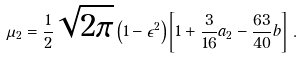Convert formula to latex. <formula><loc_0><loc_0><loc_500><loc_500>\mu _ { 2 } = \frac { 1 } { 2 } \sqrt { 2 \pi } \left ( 1 - \epsilon ^ { 2 } \right ) \left [ 1 + \frac { 3 } { 1 6 } a _ { 2 } - \frac { 6 3 } { 4 0 } b \right ] \, .</formula> 